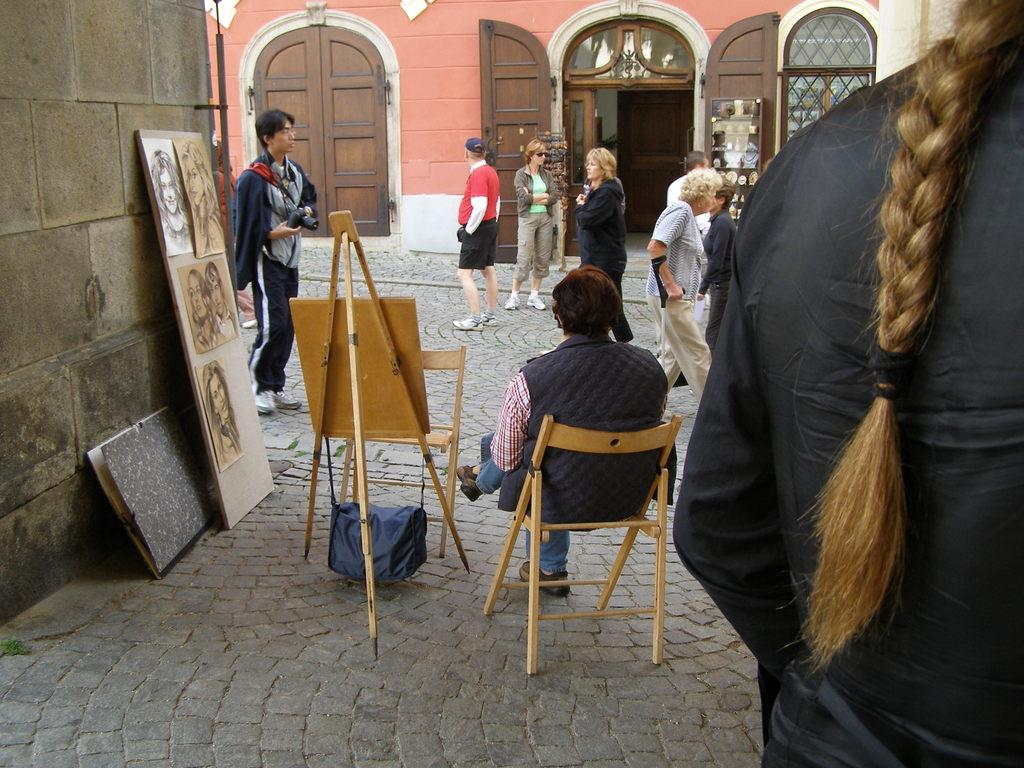What is the girl in the image doing? The girl is standing in the image. What is the position of the person in the image? There is a person sitting on a chair in the image. Can you describe a feature of the room in the image? There is a door in the image. What is the action of the person in the image? There is a person walking in the image. What type of objects can be seen on the wall in the image? There are photos in the image. What allows natural light to enter the room in the image? There is a window in the image. What is the girl learning in the image? There is no indication in the image that the girl is learning anything. What type of thing is the person sitting on in the image? The person is sitting on a chair, which is a piece of furniture, not a "thing." 